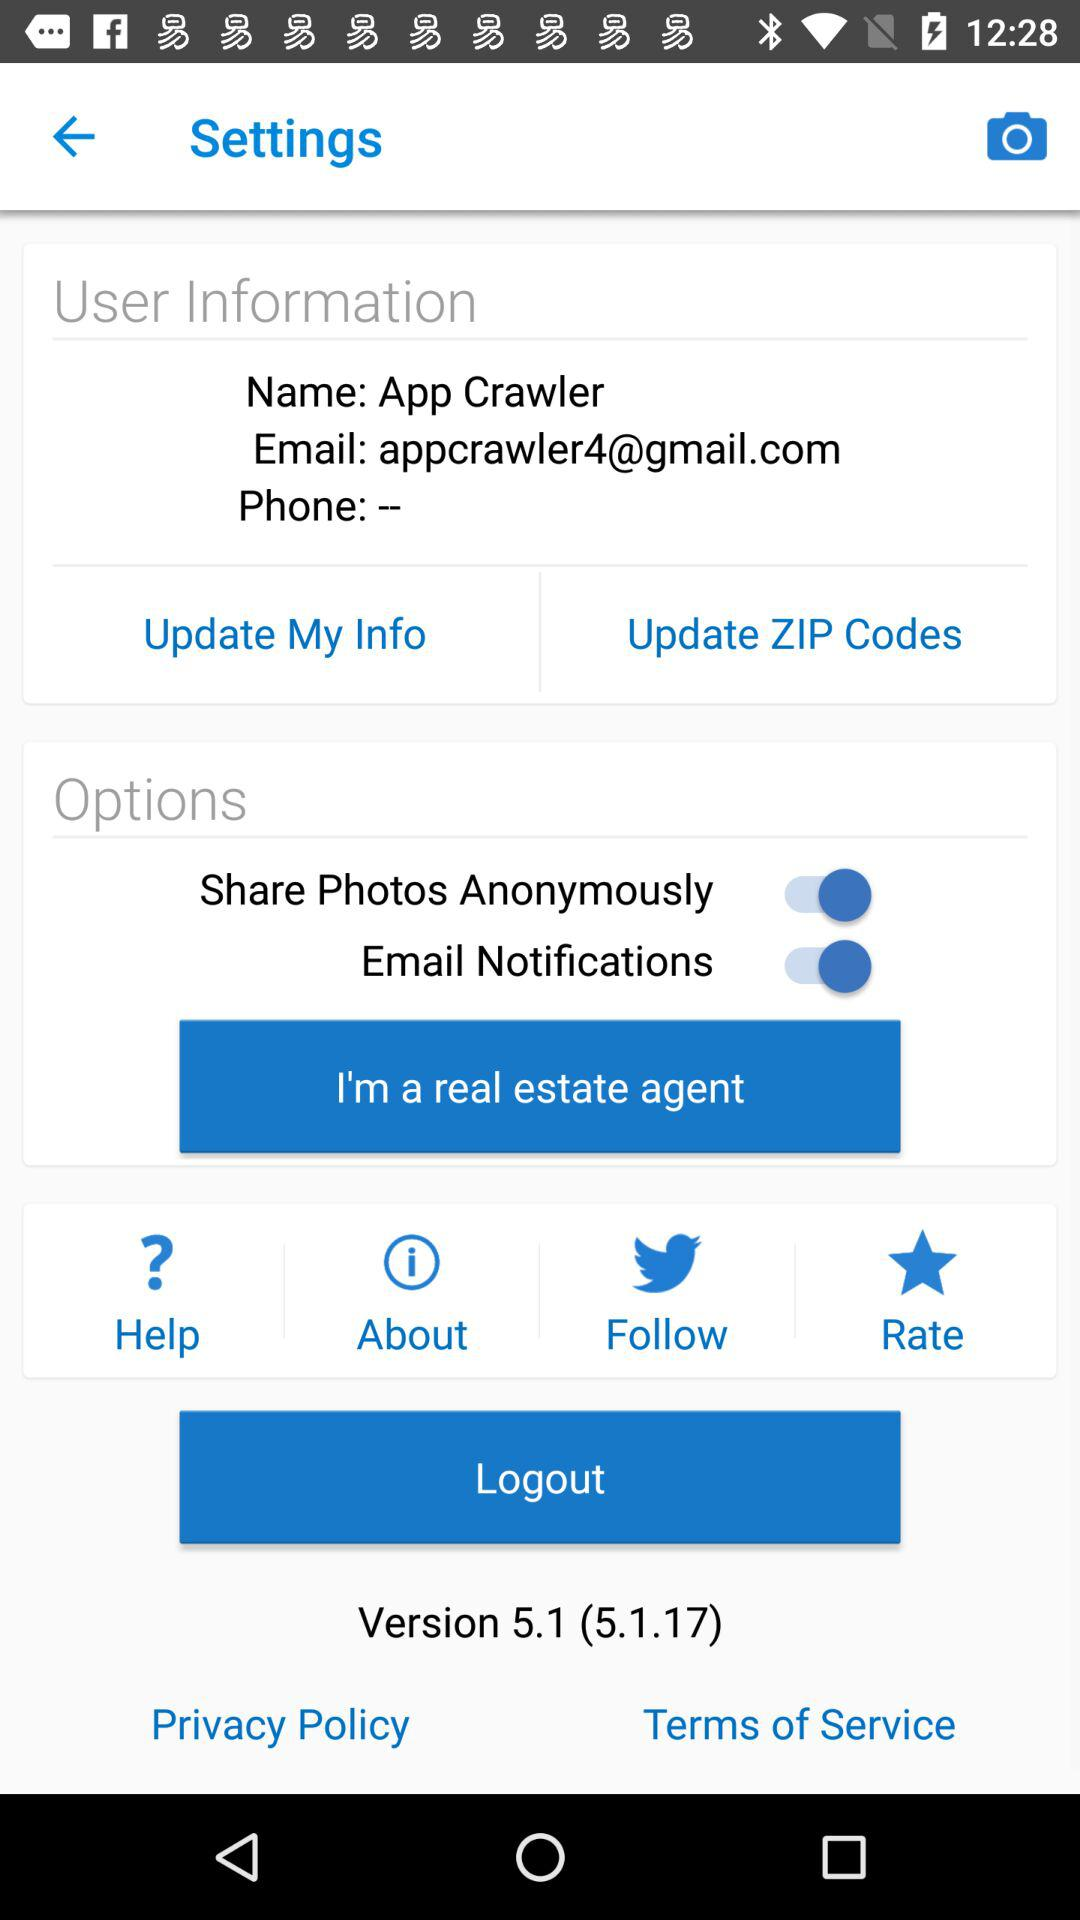What is the version of the application? The version of the application is 5.1 (5.1.17). 